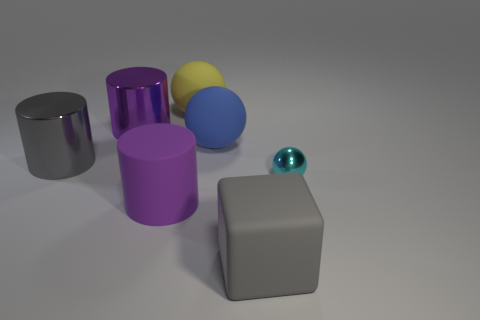Subtract all purple cylinders. Subtract all yellow balls. How many cylinders are left? 1 Add 1 large metallic things. How many objects exist? 8 Subtract all balls. How many objects are left? 4 Add 1 tiny metal spheres. How many tiny metal spheres are left? 2 Add 2 cyan spheres. How many cyan spheres exist? 3 Subtract 0 green cubes. How many objects are left? 7 Subtract all big metal things. Subtract all large gray matte things. How many objects are left? 4 